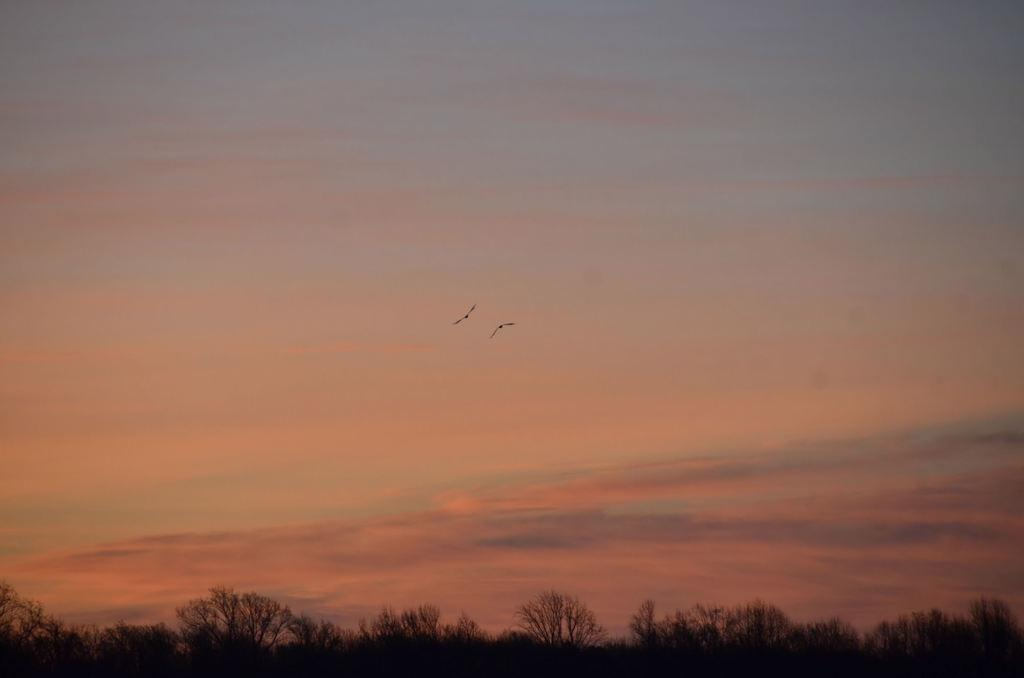What is happening in the sky in the image? There are two birds flying in the sky. What can be seen on the ground in the image? There are many trees on the ground. Where are the ants located in the image? There are no ants present in the image. What type of assistance can be provided by the ocean in the image? There is no ocean present in the image. 